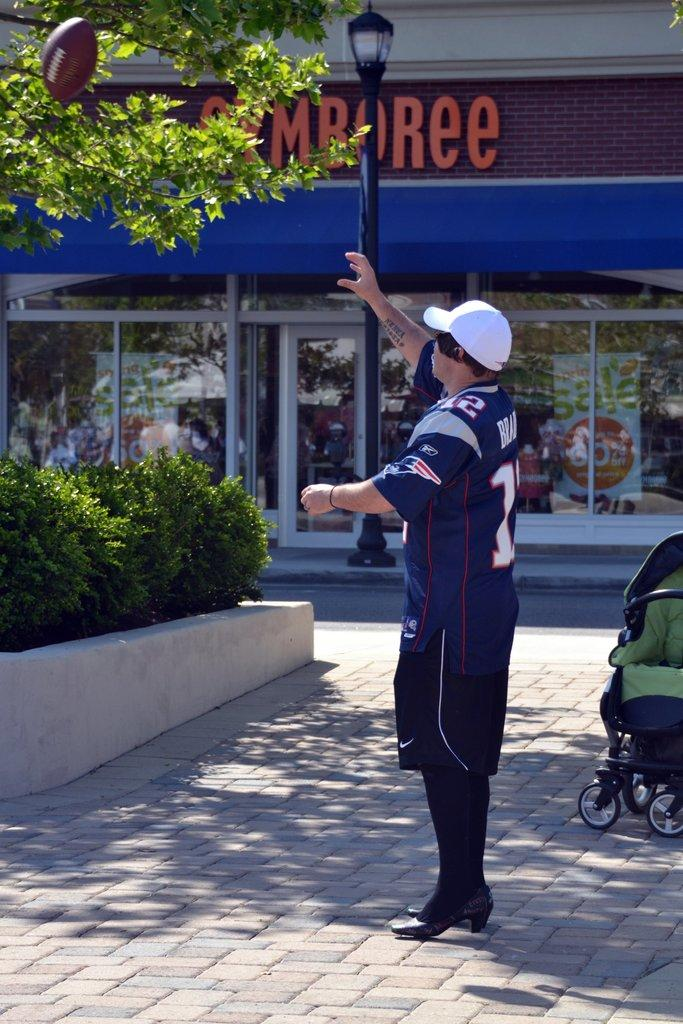What is the man in the image doing? The man is standing in the image. Can you describe what the man is wearing? The man is wearing a cap. What object is in the air in the image? There is a rugby ball in the air. What can be seen in the background of the image? Trees and a building are visible in the background. What type of bells can be heard ringing in the image? There are no bells present in the image, and therefore no sound can be heard. Can you see a net in the image? There is no net visible in the image. 